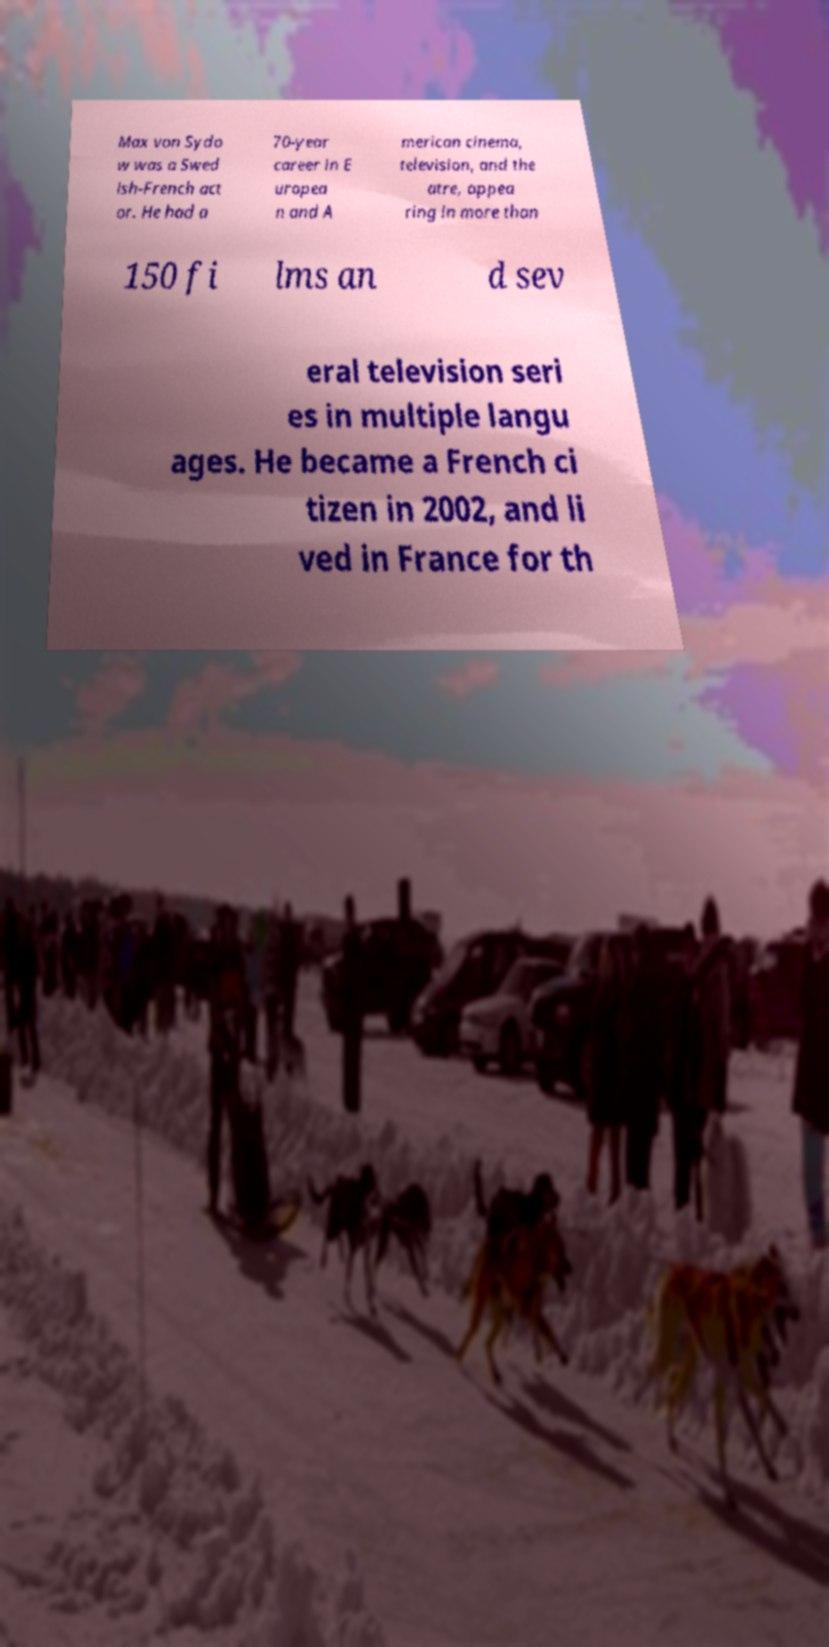Could you assist in decoding the text presented in this image and type it out clearly? Max von Sydo w was a Swed ish-French act or. He had a 70-year career in E uropea n and A merican cinema, television, and the atre, appea ring in more than 150 fi lms an d sev eral television seri es in multiple langu ages. He became a French ci tizen in 2002, and li ved in France for th 